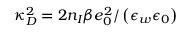Convert formula to latex. <formula><loc_0><loc_0><loc_500><loc_500>\kappa _ { D } ^ { 2 } = 2 n _ { I } \beta e _ { 0 } ^ { 2 } / \left ( \epsilon _ { w } \epsilon _ { 0 } \right )</formula> 